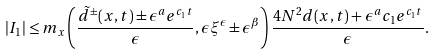<formula> <loc_0><loc_0><loc_500><loc_500>| I _ { 1 } | \leq m _ { x } \left ( \frac { \tilde { d } ^ { \pm } ( x , t ) \pm \epsilon ^ { a } e ^ { c _ { 1 } t } } { \epsilon } , \epsilon \xi ^ { \epsilon } \pm \epsilon ^ { \beta } \right ) \frac { 4 N ^ { 2 } d ( x , t ) + \epsilon ^ { a } c _ { 1 } e ^ { c _ { 1 } t } } { \epsilon } .</formula> 